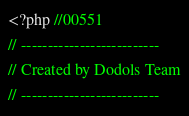<code> <loc_0><loc_0><loc_500><loc_500><_PHP_><?php //00551
// --------------------------
// Created by Dodols Team
// --------------------------</code> 